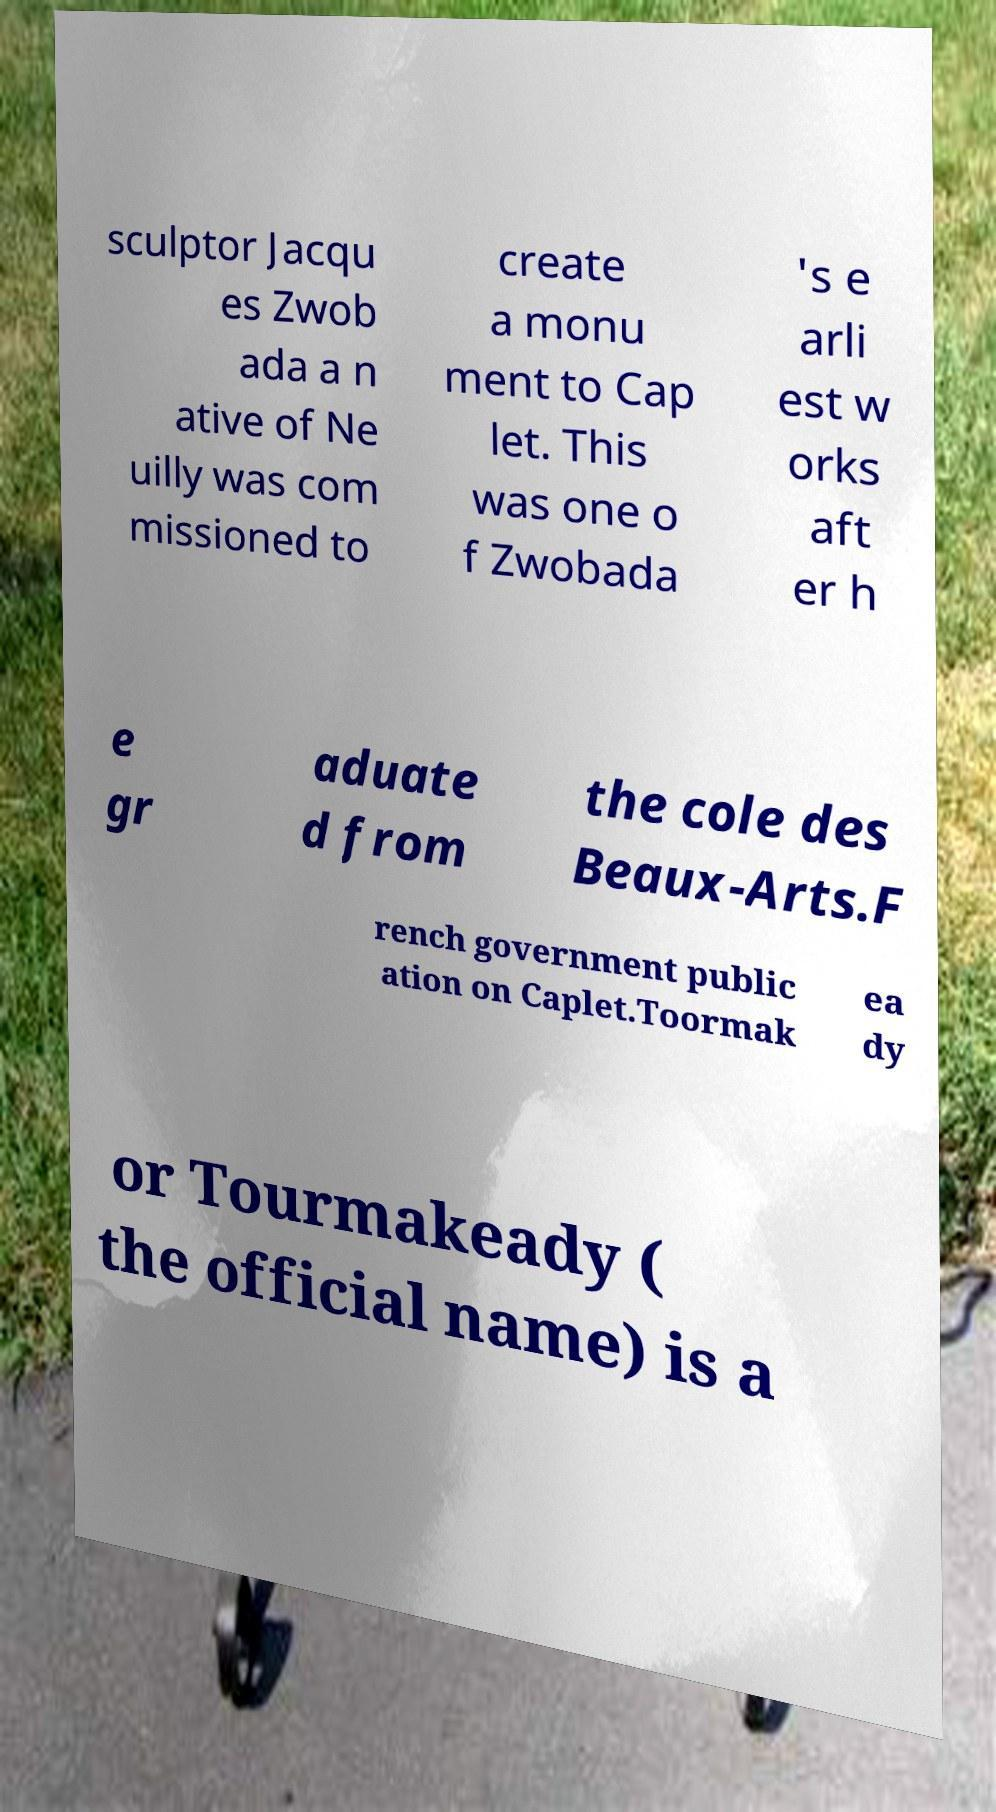Can you accurately transcribe the text from the provided image for me? sculptor Jacqu es Zwob ada a n ative of Ne uilly was com missioned to create a monu ment to Cap let. This was one o f Zwobada 's e arli est w orks aft er h e gr aduate d from the cole des Beaux-Arts.F rench government public ation on Caplet.Toormak ea dy or Tourmakeady ( the official name) is a 